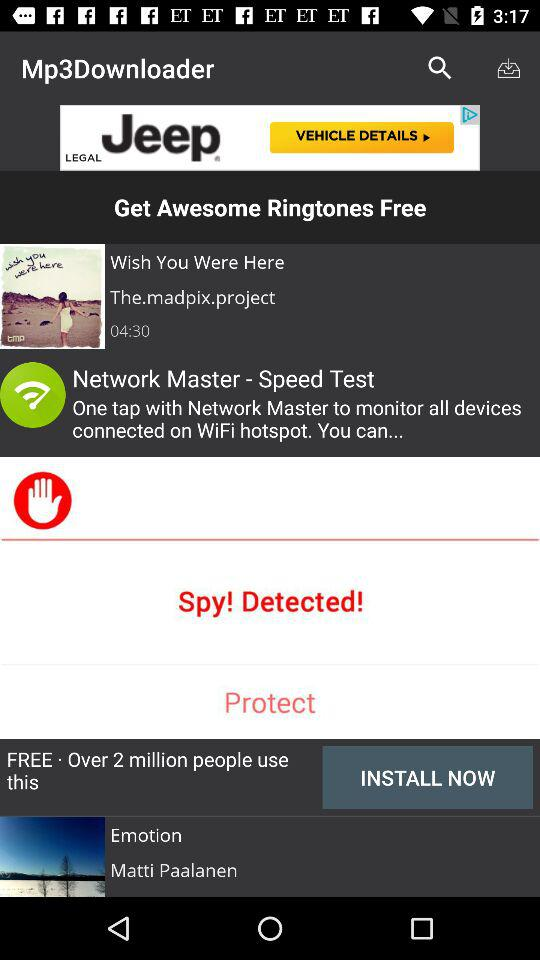What is the name of the production company for the album?
When the provided information is insufficient, respond with <no answer>. <no answer> 